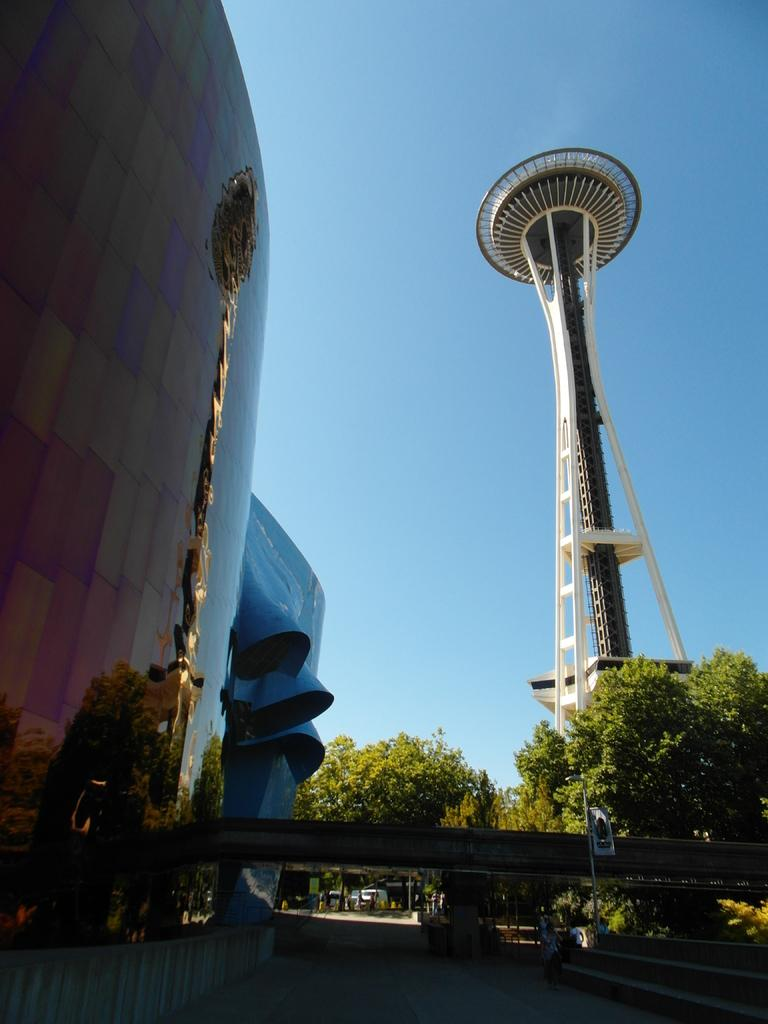What type of structure is present in the image? There is a building in the image. What other architectural feature can be seen in the image? There is a tower in the image. What type of natural elements are present in the image? There are trees in the image. What type of man-made structure is present in the image that allows people to cross a body of water? There is a bridge in the image. What type of feature is present in the image that allows people to move between different levels? There are stairs in the image. How many legs can be seen on the celery in the image? There is no celery present in the image, so it is not possible to determine the number of legs on any celery. 